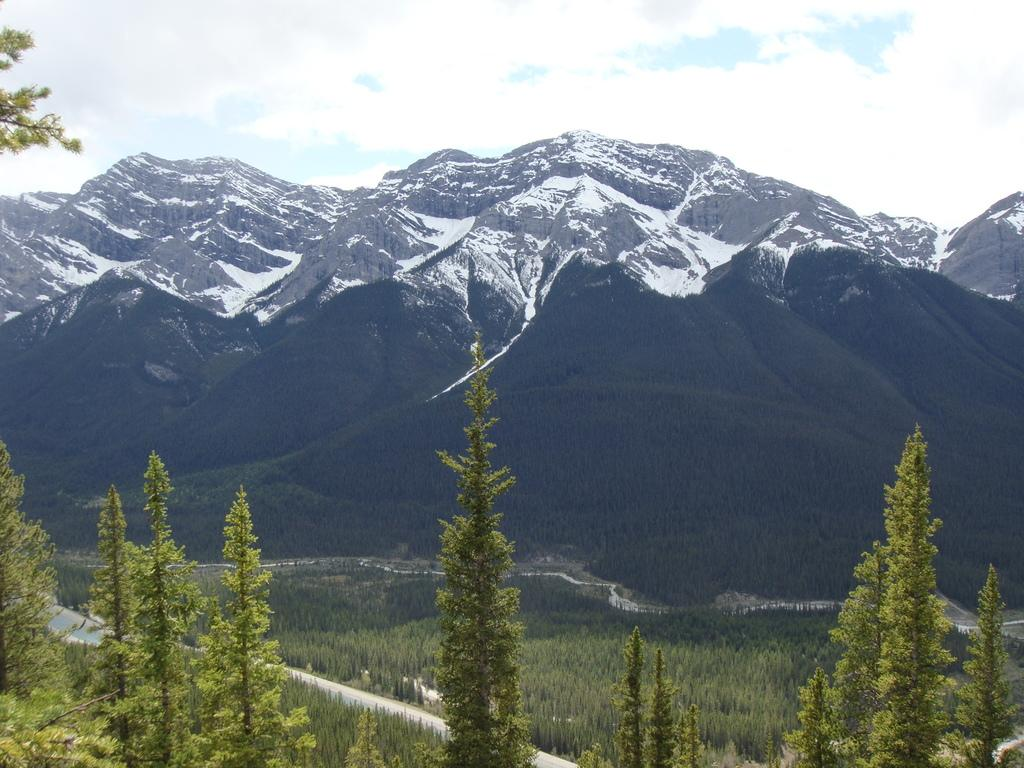What type of vegetation is at the bottom of the image? There are trees at the bottom of the image. What can be seen in the distance in the image? Hills, trees, roads, and snow are visible in the background. What is the condition of the sky in the image? The sky is cloudy at the top of the image. How does the bomb affect the comfort of the trees in the image? There is no bomb present in the image, so it cannot affect the comfort of the trees. What type of tramp can be seen interacting with the trees in the image? There is no tramp present in the image; only trees, hills, roads, snow, and a cloudy sky are visible. 